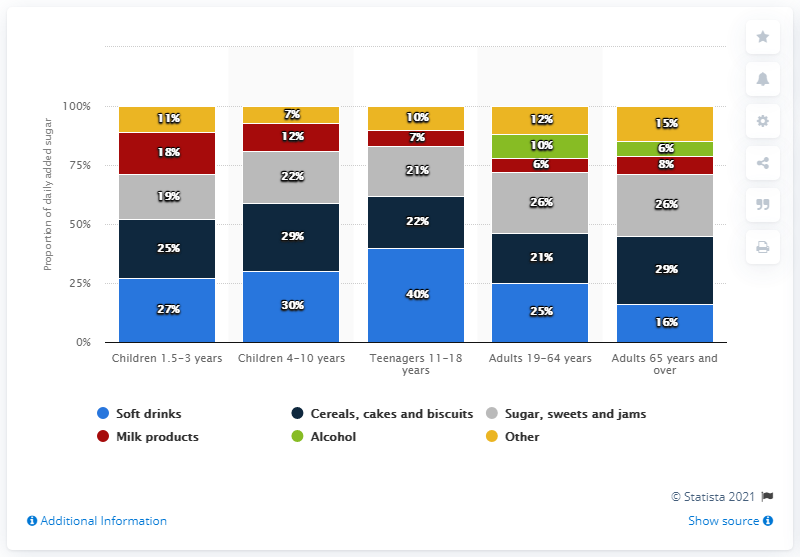Outline some significant characteristics in this image. Adults between the ages of 19 and 64 received an average of 25 grams of added sugar per day, according to data. 